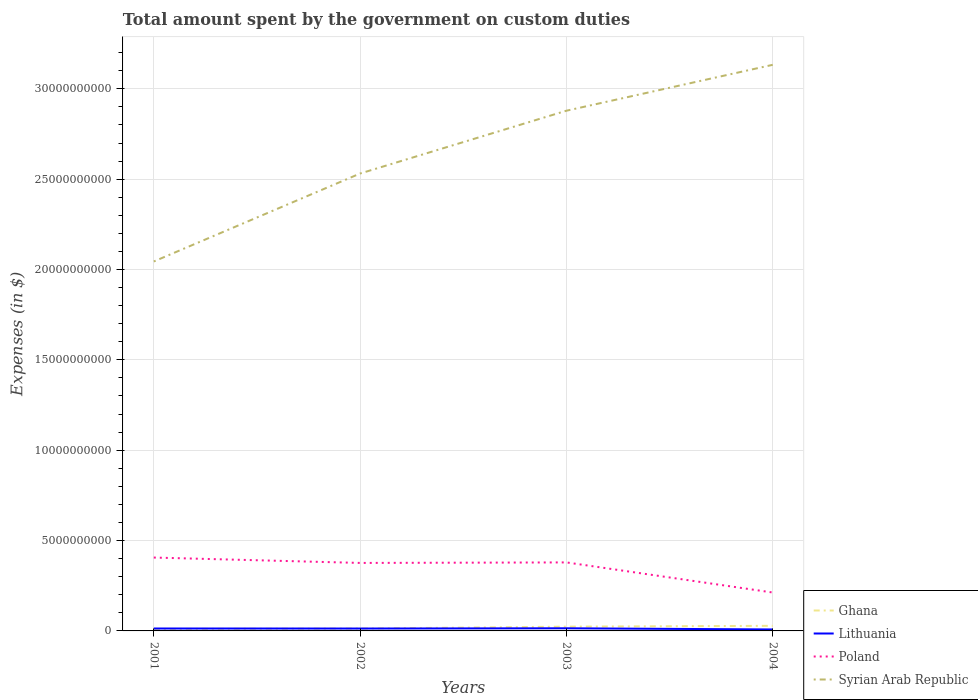How many different coloured lines are there?
Ensure brevity in your answer.  4. Does the line corresponding to Syrian Arab Republic intersect with the line corresponding to Lithuania?
Keep it short and to the point. No. Across all years, what is the maximum amount spent on custom duties by the government in Lithuania?
Ensure brevity in your answer.  8.14e+07. In which year was the amount spent on custom duties by the government in Syrian Arab Republic maximum?
Keep it short and to the point. 2001. What is the total amount spent on custom duties by the government in Poland in the graph?
Your response must be concise. 2.69e+08. What is the difference between the highest and the second highest amount spent on custom duties by the government in Lithuania?
Keep it short and to the point. 6.49e+07. How many lines are there?
Your response must be concise. 4. How many years are there in the graph?
Your answer should be very brief. 4. Are the values on the major ticks of Y-axis written in scientific E-notation?
Provide a succinct answer. No. Does the graph contain grids?
Your answer should be compact. Yes. Where does the legend appear in the graph?
Offer a terse response. Bottom right. How many legend labels are there?
Offer a very short reply. 4. How are the legend labels stacked?
Your answer should be very brief. Vertical. What is the title of the graph?
Ensure brevity in your answer.  Total amount spent by the government on custom duties. Does "St. Martin (French part)" appear as one of the legend labels in the graph?
Provide a short and direct response. No. What is the label or title of the Y-axis?
Your response must be concise. Expenses (in $). What is the Expenses (in $) of Ghana in 2001?
Your answer should be very brief. 1.06e+08. What is the Expenses (in $) in Lithuania in 2001?
Keep it short and to the point. 1.34e+08. What is the Expenses (in $) of Poland in 2001?
Provide a short and direct response. 4.06e+09. What is the Expenses (in $) in Syrian Arab Republic in 2001?
Provide a succinct answer. 2.04e+1. What is the Expenses (in $) of Ghana in 2002?
Offer a very short reply. 1.32e+08. What is the Expenses (in $) of Lithuania in 2002?
Keep it short and to the point. 1.32e+08. What is the Expenses (in $) of Poland in 2002?
Make the answer very short. 3.76e+09. What is the Expenses (in $) of Syrian Arab Republic in 2002?
Ensure brevity in your answer.  2.53e+1. What is the Expenses (in $) in Ghana in 2003?
Keep it short and to the point. 2.37e+08. What is the Expenses (in $) in Lithuania in 2003?
Your answer should be compact. 1.46e+08. What is the Expenses (in $) in Poland in 2003?
Your answer should be compact. 3.79e+09. What is the Expenses (in $) of Syrian Arab Republic in 2003?
Your response must be concise. 2.88e+1. What is the Expenses (in $) in Ghana in 2004?
Keep it short and to the point. 2.82e+08. What is the Expenses (in $) in Lithuania in 2004?
Your response must be concise. 8.14e+07. What is the Expenses (in $) of Poland in 2004?
Give a very brief answer. 2.12e+09. What is the Expenses (in $) in Syrian Arab Republic in 2004?
Keep it short and to the point. 3.13e+1. Across all years, what is the maximum Expenses (in $) in Ghana?
Your response must be concise. 2.82e+08. Across all years, what is the maximum Expenses (in $) of Lithuania?
Your answer should be compact. 1.46e+08. Across all years, what is the maximum Expenses (in $) of Poland?
Offer a very short reply. 4.06e+09. Across all years, what is the maximum Expenses (in $) of Syrian Arab Republic?
Offer a very short reply. 3.13e+1. Across all years, what is the minimum Expenses (in $) in Ghana?
Your answer should be compact. 1.06e+08. Across all years, what is the minimum Expenses (in $) in Lithuania?
Provide a succinct answer. 8.14e+07. Across all years, what is the minimum Expenses (in $) in Poland?
Make the answer very short. 2.12e+09. Across all years, what is the minimum Expenses (in $) in Syrian Arab Republic?
Provide a short and direct response. 2.04e+1. What is the total Expenses (in $) in Ghana in the graph?
Give a very brief answer. 7.57e+08. What is the total Expenses (in $) of Lithuania in the graph?
Make the answer very short. 4.94e+08. What is the total Expenses (in $) of Poland in the graph?
Provide a short and direct response. 1.37e+1. What is the total Expenses (in $) in Syrian Arab Republic in the graph?
Your answer should be very brief. 1.06e+11. What is the difference between the Expenses (in $) in Ghana in 2001 and that in 2002?
Offer a very short reply. -2.56e+07. What is the difference between the Expenses (in $) in Lithuania in 2001 and that in 2002?
Offer a terse response. 1.30e+06. What is the difference between the Expenses (in $) of Poland in 2001 and that in 2002?
Your response must be concise. 2.98e+08. What is the difference between the Expenses (in $) in Syrian Arab Republic in 2001 and that in 2002?
Your response must be concise. -4.87e+09. What is the difference between the Expenses (in $) of Ghana in 2001 and that in 2003?
Offer a terse response. -1.31e+08. What is the difference between the Expenses (in $) in Lithuania in 2001 and that in 2003?
Provide a short and direct response. -1.25e+07. What is the difference between the Expenses (in $) in Poland in 2001 and that in 2003?
Offer a terse response. 2.69e+08. What is the difference between the Expenses (in $) of Syrian Arab Republic in 2001 and that in 2003?
Ensure brevity in your answer.  -8.34e+09. What is the difference between the Expenses (in $) in Ghana in 2001 and that in 2004?
Offer a terse response. -1.76e+08. What is the difference between the Expenses (in $) in Lithuania in 2001 and that in 2004?
Provide a succinct answer. 5.24e+07. What is the difference between the Expenses (in $) of Poland in 2001 and that in 2004?
Make the answer very short. 1.94e+09. What is the difference between the Expenses (in $) in Syrian Arab Republic in 2001 and that in 2004?
Provide a succinct answer. -1.09e+1. What is the difference between the Expenses (in $) of Ghana in 2002 and that in 2003?
Offer a very short reply. -1.05e+08. What is the difference between the Expenses (in $) in Lithuania in 2002 and that in 2003?
Offer a terse response. -1.38e+07. What is the difference between the Expenses (in $) of Poland in 2002 and that in 2003?
Your answer should be compact. -2.90e+07. What is the difference between the Expenses (in $) of Syrian Arab Republic in 2002 and that in 2003?
Ensure brevity in your answer.  -3.48e+09. What is the difference between the Expenses (in $) of Ghana in 2002 and that in 2004?
Your answer should be compact. -1.51e+08. What is the difference between the Expenses (in $) in Lithuania in 2002 and that in 2004?
Keep it short and to the point. 5.11e+07. What is the difference between the Expenses (in $) in Poland in 2002 and that in 2004?
Your response must be concise. 1.64e+09. What is the difference between the Expenses (in $) in Syrian Arab Republic in 2002 and that in 2004?
Offer a very short reply. -6.02e+09. What is the difference between the Expenses (in $) in Ghana in 2003 and that in 2004?
Provide a succinct answer. -4.56e+07. What is the difference between the Expenses (in $) of Lithuania in 2003 and that in 2004?
Your answer should be compact. 6.49e+07. What is the difference between the Expenses (in $) of Poland in 2003 and that in 2004?
Provide a short and direct response. 1.67e+09. What is the difference between the Expenses (in $) in Syrian Arab Republic in 2003 and that in 2004?
Offer a terse response. -2.54e+09. What is the difference between the Expenses (in $) of Ghana in 2001 and the Expenses (in $) of Lithuania in 2002?
Provide a succinct answer. -2.65e+07. What is the difference between the Expenses (in $) in Ghana in 2001 and the Expenses (in $) in Poland in 2002?
Your answer should be compact. -3.66e+09. What is the difference between the Expenses (in $) of Ghana in 2001 and the Expenses (in $) of Syrian Arab Republic in 2002?
Keep it short and to the point. -2.52e+1. What is the difference between the Expenses (in $) in Lithuania in 2001 and the Expenses (in $) in Poland in 2002?
Offer a very short reply. -3.63e+09. What is the difference between the Expenses (in $) of Lithuania in 2001 and the Expenses (in $) of Syrian Arab Republic in 2002?
Your response must be concise. -2.52e+1. What is the difference between the Expenses (in $) of Poland in 2001 and the Expenses (in $) of Syrian Arab Republic in 2002?
Provide a succinct answer. -2.13e+1. What is the difference between the Expenses (in $) in Ghana in 2001 and the Expenses (in $) in Lithuania in 2003?
Offer a terse response. -4.03e+07. What is the difference between the Expenses (in $) of Ghana in 2001 and the Expenses (in $) of Poland in 2003?
Ensure brevity in your answer.  -3.69e+09. What is the difference between the Expenses (in $) in Ghana in 2001 and the Expenses (in $) in Syrian Arab Republic in 2003?
Make the answer very short. -2.87e+1. What is the difference between the Expenses (in $) in Lithuania in 2001 and the Expenses (in $) in Poland in 2003?
Provide a succinct answer. -3.66e+09. What is the difference between the Expenses (in $) of Lithuania in 2001 and the Expenses (in $) of Syrian Arab Republic in 2003?
Ensure brevity in your answer.  -2.87e+1. What is the difference between the Expenses (in $) of Poland in 2001 and the Expenses (in $) of Syrian Arab Republic in 2003?
Make the answer very short. -2.47e+1. What is the difference between the Expenses (in $) of Ghana in 2001 and the Expenses (in $) of Lithuania in 2004?
Give a very brief answer. 2.46e+07. What is the difference between the Expenses (in $) of Ghana in 2001 and the Expenses (in $) of Poland in 2004?
Provide a succinct answer. -2.02e+09. What is the difference between the Expenses (in $) of Ghana in 2001 and the Expenses (in $) of Syrian Arab Republic in 2004?
Your answer should be compact. -3.12e+1. What is the difference between the Expenses (in $) of Lithuania in 2001 and the Expenses (in $) of Poland in 2004?
Provide a short and direct response. -1.99e+09. What is the difference between the Expenses (in $) of Lithuania in 2001 and the Expenses (in $) of Syrian Arab Republic in 2004?
Your response must be concise. -3.12e+1. What is the difference between the Expenses (in $) in Poland in 2001 and the Expenses (in $) in Syrian Arab Republic in 2004?
Offer a very short reply. -2.73e+1. What is the difference between the Expenses (in $) of Ghana in 2002 and the Expenses (in $) of Lithuania in 2003?
Provide a short and direct response. -1.47e+07. What is the difference between the Expenses (in $) in Ghana in 2002 and the Expenses (in $) in Poland in 2003?
Ensure brevity in your answer.  -3.66e+09. What is the difference between the Expenses (in $) in Ghana in 2002 and the Expenses (in $) in Syrian Arab Republic in 2003?
Provide a short and direct response. -2.87e+1. What is the difference between the Expenses (in $) of Lithuania in 2002 and the Expenses (in $) of Poland in 2003?
Make the answer very short. -3.66e+09. What is the difference between the Expenses (in $) in Lithuania in 2002 and the Expenses (in $) in Syrian Arab Republic in 2003?
Keep it short and to the point. -2.87e+1. What is the difference between the Expenses (in $) of Poland in 2002 and the Expenses (in $) of Syrian Arab Republic in 2003?
Keep it short and to the point. -2.50e+1. What is the difference between the Expenses (in $) in Ghana in 2002 and the Expenses (in $) in Lithuania in 2004?
Provide a succinct answer. 5.02e+07. What is the difference between the Expenses (in $) of Ghana in 2002 and the Expenses (in $) of Poland in 2004?
Your answer should be compact. -1.99e+09. What is the difference between the Expenses (in $) of Ghana in 2002 and the Expenses (in $) of Syrian Arab Republic in 2004?
Offer a terse response. -3.12e+1. What is the difference between the Expenses (in $) of Lithuania in 2002 and the Expenses (in $) of Poland in 2004?
Provide a short and direct response. -1.99e+09. What is the difference between the Expenses (in $) in Lithuania in 2002 and the Expenses (in $) in Syrian Arab Republic in 2004?
Give a very brief answer. -3.12e+1. What is the difference between the Expenses (in $) in Poland in 2002 and the Expenses (in $) in Syrian Arab Republic in 2004?
Your answer should be compact. -2.76e+1. What is the difference between the Expenses (in $) in Ghana in 2003 and the Expenses (in $) in Lithuania in 2004?
Your answer should be compact. 1.55e+08. What is the difference between the Expenses (in $) in Ghana in 2003 and the Expenses (in $) in Poland in 2004?
Offer a very short reply. -1.89e+09. What is the difference between the Expenses (in $) in Ghana in 2003 and the Expenses (in $) in Syrian Arab Republic in 2004?
Keep it short and to the point. -3.11e+1. What is the difference between the Expenses (in $) in Lithuania in 2003 and the Expenses (in $) in Poland in 2004?
Your answer should be very brief. -1.98e+09. What is the difference between the Expenses (in $) in Lithuania in 2003 and the Expenses (in $) in Syrian Arab Republic in 2004?
Provide a short and direct response. -3.12e+1. What is the difference between the Expenses (in $) of Poland in 2003 and the Expenses (in $) of Syrian Arab Republic in 2004?
Make the answer very short. -2.75e+1. What is the average Expenses (in $) of Ghana per year?
Give a very brief answer. 1.89e+08. What is the average Expenses (in $) of Lithuania per year?
Provide a short and direct response. 1.24e+08. What is the average Expenses (in $) in Poland per year?
Provide a short and direct response. 3.43e+09. What is the average Expenses (in $) of Syrian Arab Republic per year?
Your answer should be very brief. 2.65e+1. In the year 2001, what is the difference between the Expenses (in $) of Ghana and Expenses (in $) of Lithuania?
Keep it short and to the point. -2.78e+07. In the year 2001, what is the difference between the Expenses (in $) in Ghana and Expenses (in $) in Poland?
Provide a short and direct response. -3.95e+09. In the year 2001, what is the difference between the Expenses (in $) in Ghana and Expenses (in $) in Syrian Arab Republic?
Your answer should be very brief. -2.03e+1. In the year 2001, what is the difference between the Expenses (in $) of Lithuania and Expenses (in $) of Poland?
Give a very brief answer. -3.93e+09. In the year 2001, what is the difference between the Expenses (in $) in Lithuania and Expenses (in $) in Syrian Arab Republic?
Offer a very short reply. -2.03e+1. In the year 2001, what is the difference between the Expenses (in $) of Poland and Expenses (in $) of Syrian Arab Republic?
Ensure brevity in your answer.  -1.64e+1. In the year 2002, what is the difference between the Expenses (in $) of Ghana and Expenses (in $) of Lithuania?
Offer a very short reply. -9.01e+05. In the year 2002, what is the difference between the Expenses (in $) of Ghana and Expenses (in $) of Poland?
Provide a succinct answer. -3.63e+09. In the year 2002, what is the difference between the Expenses (in $) of Ghana and Expenses (in $) of Syrian Arab Republic?
Your answer should be very brief. -2.52e+1. In the year 2002, what is the difference between the Expenses (in $) in Lithuania and Expenses (in $) in Poland?
Give a very brief answer. -3.63e+09. In the year 2002, what is the difference between the Expenses (in $) in Lithuania and Expenses (in $) in Syrian Arab Republic?
Provide a short and direct response. -2.52e+1. In the year 2002, what is the difference between the Expenses (in $) in Poland and Expenses (in $) in Syrian Arab Republic?
Your answer should be very brief. -2.16e+1. In the year 2003, what is the difference between the Expenses (in $) in Ghana and Expenses (in $) in Lithuania?
Keep it short and to the point. 9.04e+07. In the year 2003, what is the difference between the Expenses (in $) of Ghana and Expenses (in $) of Poland?
Give a very brief answer. -3.55e+09. In the year 2003, what is the difference between the Expenses (in $) in Ghana and Expenses (in $) in Syrian Arab Republic?
Keep it short and to the point. -2.86e+1. In the year 2003, what is the difference between the Expenses (in $) in Lithuania and Expenses (in $) in Poland?
Your response must be concise. -3.64e+09. In the year 2003, what is the difference between the Expenses (in $) in Lithuania and Expenses (in $) in Syrian Arab Republic?
Offer a terse response. -2.86e+1. In the year 2003, what is the difference between the Expenses (in $) in Poland and Expenses (in $) in Syrian Arab Republic?
Keep it short and to the point. -2.50e+1. In the year 2004, what is the difference between the Expenses (in $) of Ghana and Expenses (in $) of Lithuania?
Make the answer very short. 2.01e+08. In the year 2004, what is the difference between the Expenses (in $) of Ghana and Expenses (in $) of Poland?
Your response must be concise. -1.84e+09. In the year 2004, what is the difference between the Expenses (in $) in Ghana and Expenses (in $) in Syrian Arab Republic?
Give a very brief answer. -3.10e+1. In the year 2004, what is the difference between the Expenses (in $) of Lithuania and Expenses (in $) of Poland?
Make the answer very short. -2.04e+09. In the year 2004, what is the difference between the Expenses (in $) of Lithuania and Expenses (in $) of Syrian Arab Republic?
Keep it short and to the point. -3.12e+1. In the year 2004, what is the difference between the Expenses (in $) of Poland and Expenses (in $) of Syrian Arab Republic?
Your answer should be compact. -2.92e+1. What is the ratio of the Expenses (in $) in Ghana in 2001 to that in 2002?
Your answer should be very brief. 0.81. What is the ratio of the Expenses (in $) of Lithuania in 2001 to that in 2002?
Keep it short and to the point. 1.01. What is the ratio of the Expenses (in $) in Poland in 2001 to that in 2002?
Provide a succinct answer. 1.08. What is the ratio of the Expenses (in $) of Syrian Arab Republic in 2001 to that in 2002?
Your answer should be compact. 0.81. What is the ratio of the Expenses (in $) in Ghana in 2001 to that in 2003?
Keep it short and to the point. 0.45. What is the ratio of the Expenses (in $) of Lithuania in 2001 to that in 2003?
Provide a succinct answer. 0.91. What is the ratio of the Expenses (in $) in Poland in 2001 to that in 2003?
Your response must be concise. 1.07. What is the ratio of the Expenses (in $) in Syrian Arab Republic in 2001 to that in 2003?
Provide a short and direct response. 0.71. What is the ratio of the Expenses (in $) in Ghana in 2001 to that in 2004?
Ensure brevity in your answer.  0.38. What is the ratio of the Expenses (in $) in Lithuania in 2001 to that in 2004?
Make the answer very short. 1.64. What is the ratio of the Expenses (in $) in Poland in 2001 to that in 2004?
Your answer should be compact. 1.91. What is the ratio of the Expenses (in $) in Syrian Arab Republic in 2001 to that in 2004?
Offer a very short reply. 0.65. What is the ratio of the Expenses (in $) in Ghana in 2002 to that in 2003?
Give a very brief answer. 0.56. What is the ratio of the Expenses (in $) of Lithuania in 2002 to that in 2003?
Provide a short and direct response. 0.91. What is the ratio of the Expenses (in $) of Syrian Arab Republic in 2002 to that in 2003?
Provide a succinct answer. 0.88. What is the ratio of the Expenses (in $) in Ghana in 2002 to that in 2004?
Your response must be concise. 0.47. What is the ratio of the Expenses (in $) in Lithuania in 2002 to that in 2004?
Ensure brevity in your answer.  1.63. What is the ratio of the Expenses (in $) of Poland in 2002 to that in 2004?
Provide a succinct answer. 1.77. What is the ratio of the Expenses (in $) in Syrian Arab Republic in 2002 to that in 2004?
Provide a short and direct response. 0.81. What is the ratio of the Expenses (in $) of Ghana in 2003 to that in 2004?
Offer a terse response. 0.84. What is the ratio of the Expenses (in $) of Lithuania in 2003 to that in 2004?
Your response must be concise. 1.8. What is the ratio of the Expenses (in $) of Poland in 2003 to that in 2004?
Your response must be concise. 1.78. What is the ratio of the Expenses (in $) of Syrian Arab Republic in 2003 to that in 2004?
Provide a short and direct response. 0.92. What is the difference between the highest and the second highest Expenses (in $) in Ghana?
Your answer should be very brief. 4.56e+07. What is the difference between the highest and the second highest Expenses (in $) of Lithuania?
Your answer should be very brief. 1.25e+07. What is the difference between the highest and the second highest Expenses (in $) in Poland?
Offer a terse response. 2.69e+08. What is the difference between the highest and the second highest Expenses (in $) in Syrian Arab Republic?
Provide a succinct answer. 2.54e+09. What is the difference between the highest and the lowest Expenses (in $) in Ghana?
Provide a succinct answer. 1.76e+08. What is the difference between the highest and the lowest Expenses (in $) in Lithuania?
Ensure brevity in your answer.  6.49e+07. What is the difference between the highest and the lowest Expenses (in $) in Poland?
Ensure brevity in your answer.  1.94e+09. What is the difference between the highest and the lowest Expenses (in $) of Syrian Arab Republic?
Provide a short and direct response. 1.09e+1. 